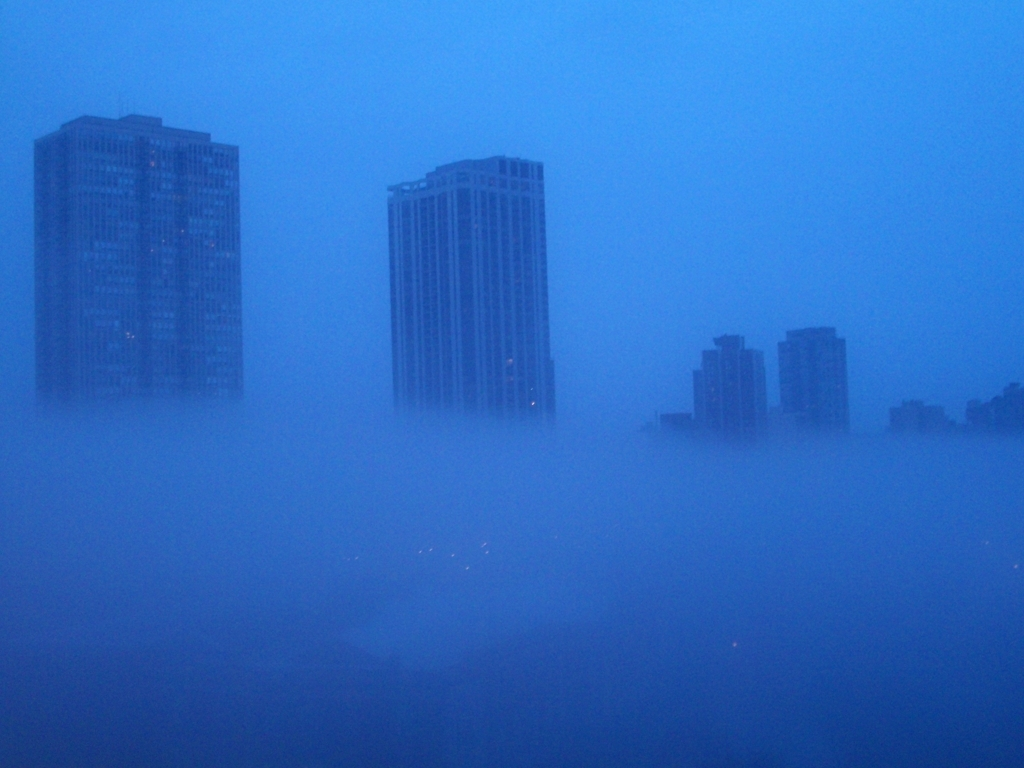If you were to imagine a soundscape for this image, what would it include? The soundscape for this image might include muted city noises, such as the distant hum of traffic or the soft blaring of car horns, all softened by the thick fog. There could be the occasional sound of footsteps echoing eerily off the buildings or the quiet rustle of wind as it moves the fog through the urban canyons. 